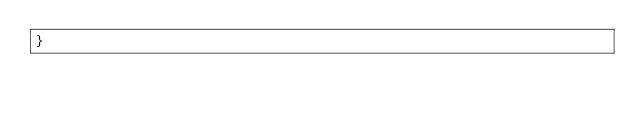Convert code to text. <code><loc_0><loc_0><loc_500><loc_500><_JavaScript_>}
</code> 